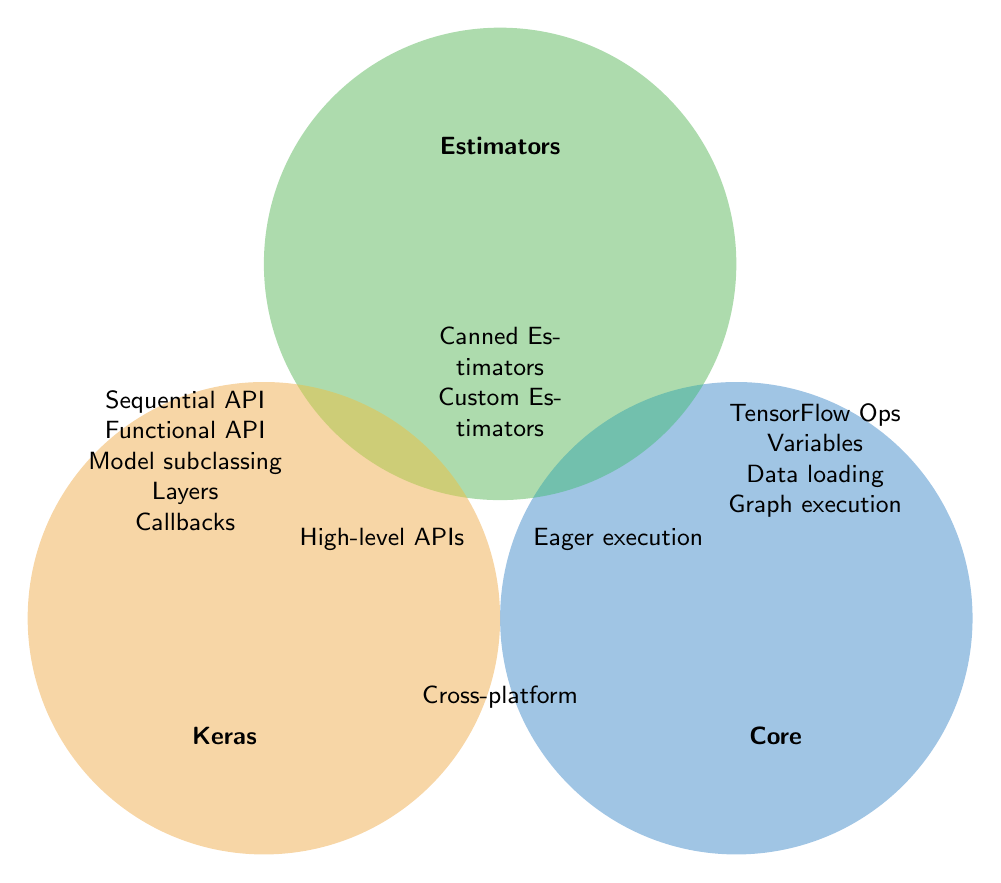What TensorFlow component does the Sequential API belong to? The Sequential API is listed under the Keras circle. Therefore, it belongs to the Keras component.
Answer: Keras Which TensorFlow component includes Eager execution and Graph execution? Eager execution is listed under Estimators and Core. Graph execution is in the Core circle. Since both are part of the Core component, Core includes both Eager execution and Graph execution.
Answer: Core What is the overlap between Keras and Estimators? The intersection of the Keras and Estimators circles is labeled 'High-level APIs', which is the shared component between them.
Answer: High-level APIs Which component includes Data loading? Data loading is shown only under the Core circle, indicating that it belongs to the Core component.
Answer: Core Is Cross-platform functionality specific to one TensorFlow component? Cross-platform is shown in the overlapping area common to Keras, Estimators, and Core, which means it is not specific to one component but shared by all.
Answer: No What TensorFlow element is specific to both Keras and Core but not included in Estimators? Eager execution is shared by all components, and the Keras and Core components don't have any exclusive overlap visible. Therefore, there is no element specific to just Keras and Core but excluded from Estimators.
Answer: None Name one TensorFlow component that includes Model subclassing and Callbacks. Both Model subclassing and Callbacks are listed under the Keras circle.
Answer: Keras Which TensorFlow component(s) include Custom Estimators? Custom Estimators is listed within the Estimators circle, indicating that it belongs to the Estimators component.
Answer: Estimators 